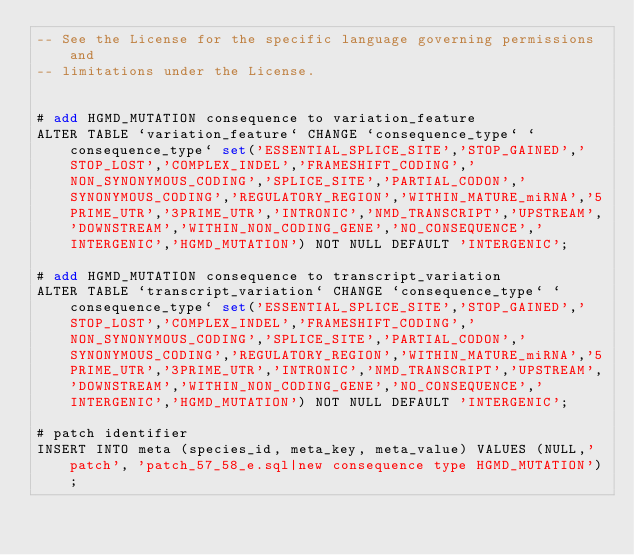<code> <loc_0><loc_0><loc_500><loc_500><_SQL_>-- See the License for the specific language governing permissions and
-- limitations under the License.


# add HGMD_MUTATION consequence to variation_feature
ALTER TABLE `variation_feature` CHANGE `consequence_type` `consequence_type` set('ESSENTIAL_SPLICE_SITE','STOP_GAINED','STOP_LOST','COMPLEX_INDEL','FRAMESHIFT_CODING','NON_SYNONYMOUS_CODING','SPLICE_SITE','PARTIAL_CODON','SYNONYMOUS_CODING','REGULATORY_REGION','WITHIN_MATURE_miRNA','5PRIME_UTR','3PRIME_UTR','INTRONIC','NMD_TRANSCRIPT','UPSTREAM','DOWNSTREAM','WITHIN_NON_CODING_GENE','NO_CONSEQUENCE','INTERGENIC','HGMD_MUTATION') NOT NULL DEFAULT 'INTERGENIC';

# add HGMD_MUTATION consequence to transcript_variation
ALTER TABLE `transcript_variation` CHANGE `consequence_type` `consequence_type` set('ESSENTIAL_SPLICE_SITE','STOP_GAINED','STOP_LOST','COMPLEX_INDEL','FRAMESHIFT_CODING','NON_SYNONYMOUS_CODING','SPLICE_SITE','PARTIAL_CODON','SYNONYMOUS_CODING','REGULATORY_REGION','WITHIN_MATURE_miRNA','5PRIME_UTR','3PRIME_UTR','INTRONIC','NMD_TRANSCRIPT','UPSTREAM','DOWNSTREAM','WITHIN_NON_CODING_GENE','NO_CONSEQUENCE','INTERGENIC','HGMD_MUTATION') NOT NULL DEFAULT 'INTERGENIC';

# patch identifier
INSERT INTO meta (species_id, meta_key, meta_value) VALUES (NULL,'patch', 'patch_57_58_e.sql|new consequence type HGMD_MUTATION');
</code> 